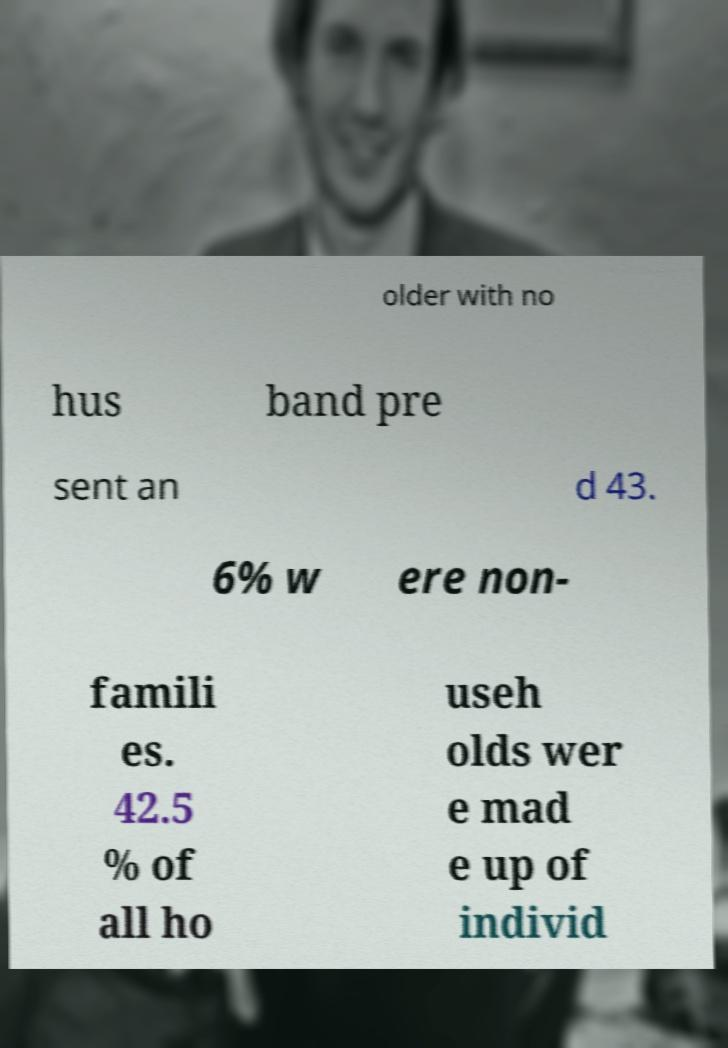Could you assist in decoding the text presented in this image and type it out clearly? older with no hus band pre sent an d 43. 6% w ere non- famili es. 42.5 % of all ho useh olds wer e mad e up of individ 